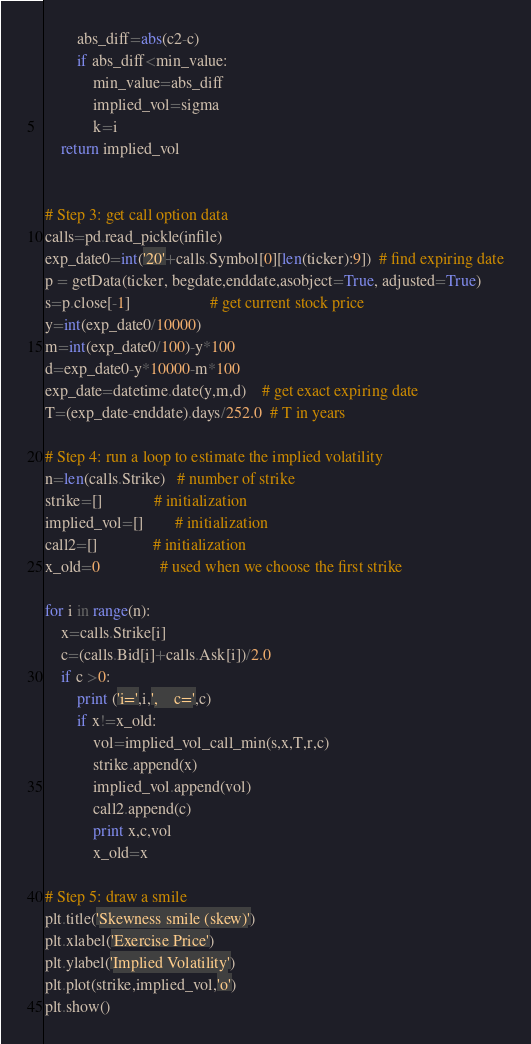Convert code to text. <code><loc_0><loc_0><loc_500><loc_500><_Python_>        abs_diff=abs(c2-c)
        if abs_diff<min_value: 
            min_value=abs_diff 
            implied_vol=sigma 
            k=i
    return implied_vol


# Step 3: get call option data 
calls=pd.read_pickle(infile)
exp_date0=int('20'+calls.Symbol[0][len(ticker):9])  # find expiring date
p = getData(ticker, begdate,enddate,asobject=True, adjusted=True)
s=p.close[-1]                    # get current stock price 
y=int(exp_date0/10000)
m=int(exp_date0/100)-y*100
d=exp_date0-y*10000-m*100
exp_date=datetime.date(y,m,d)    # get exact expiring date 
T=(exp_date-enddate).days/252.0  # T in years

# Step 4: run a loop to estimate the implied volatility 
n=len(calls.Strike)   # number of strike
strike=[]             # initialization
implied_vol=[]        # initialization
call2=[]              # initialization
x_old=0               # used when we choose the first strike 

for i in range(n):
    x=calls.Strike[i]
    c=(calls.Bid[i]+calls.Ask[i])/2.0
    if c >0:
        print ('i=',i,',    c=',c)
        if x!=x_old:
            vol=implied_vol_call_min(s,x,T,r,c)
            strike.append(x)
            implied_vol.append(vol)
            call2.append(c)
            print x,c,vol
            x_old=x

# Step 5: draw a smile 
plt.title('Skewness smile (skew)') 
plt.xlabel('Exercise Price') 
plt.ylabel('Implied Volatility')
plt.plot(strike,implied_vol,'o')
plt.show()
</code> 